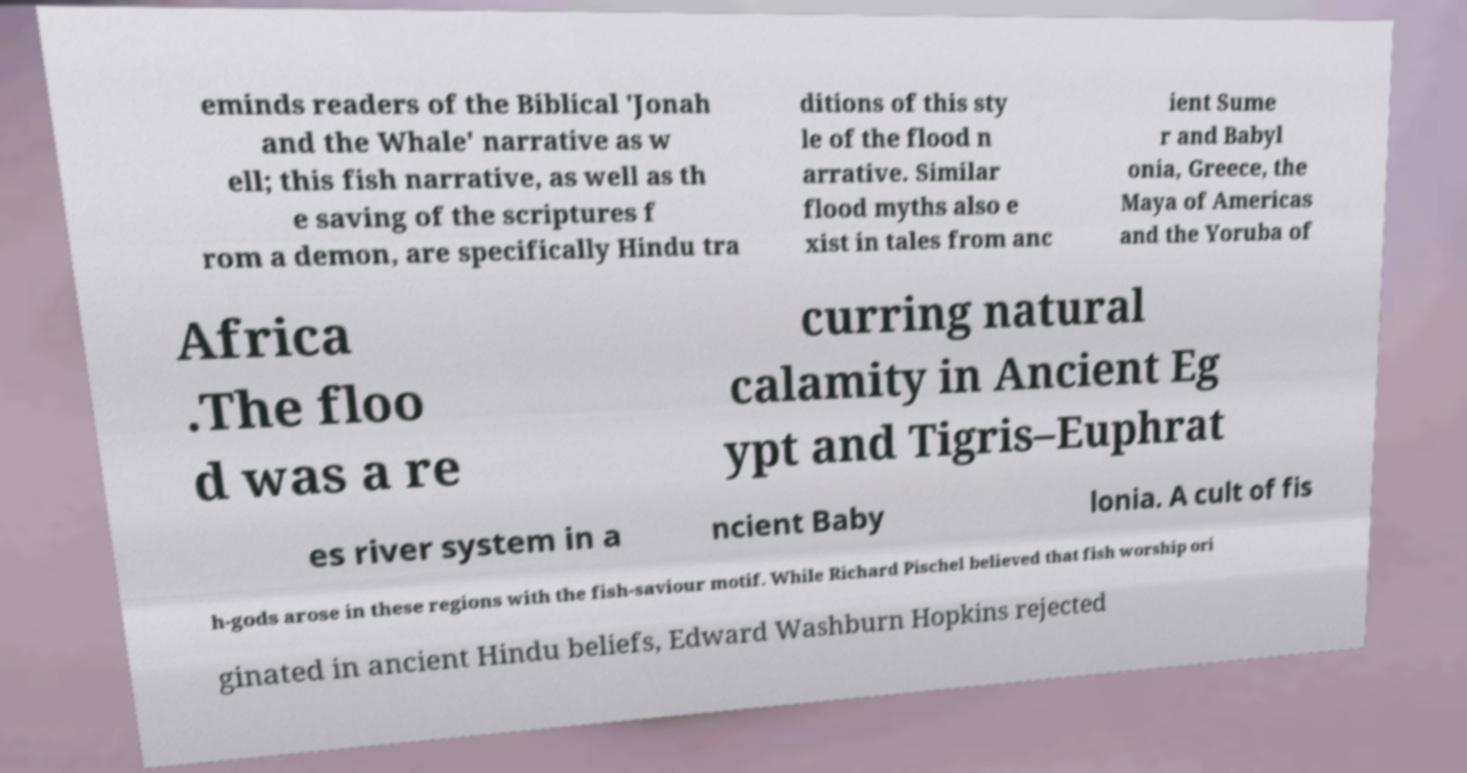I need the written content from this picture converted into text. Can you do that? eminds readers of the Biblical 'Jonah and the Whale' narrative as w ell; this fish narrative, as well as th e saving of the scriptures f rom a demon, are specifically Hindu tra ditions of this sty le of the flood n arrative. Similar flood myths also e xist in tales from anc ient Sume r and Babyl onia, Greece, the Maya of Americas and the Yoruba of Africa .The floo d was a re curring natural calamity in Ancient Eg ypt and Tigris–Euphrat es river system in a ncient Baby lonia. A cult of fis h-gods arose in these regions with the fish-saviour motif. While Richard Pischel believed that fish worship ori ginated in ancient Hindu beliefs, Edward Washburn Hopkins rejected 